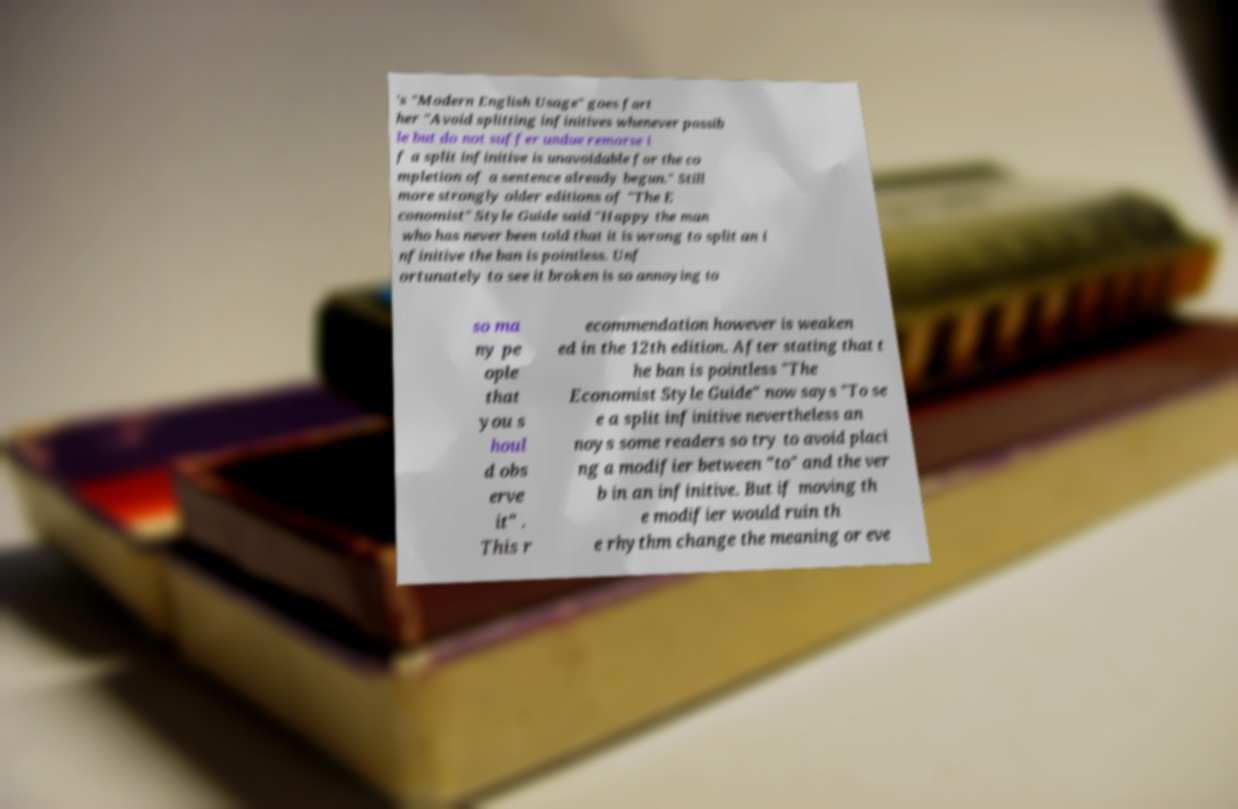What messages or text are displayed in this image? I need them in a readable, typed format. 's "Modern English Usage" goes fart her "Avoid splitting infinitives whenever possib le but do not suffer undue remorse i f a split infinitive is unavoidable for the co mpletion of a sentence already begun." Still more strongly older editions of "The E conomist" Style Guide said "Happy the man who has never been told that it is wrong to split an i nfinitive the ban is pointless. Unf ortunately to see it broken is so annoying to so ma ny pe ople that you s houl d obs erve it" . This r ecommendation however is weaken ed in the 12th edition. After stating that t he ban is pointless "The Economist Style Guide" now says "To se e a split infinitive nevertheless an noys some readers so try to avoid placi ng a modifier between "to" and the ver b in an infinitive. But if moving th e modifier would ruin th e rhythm change the meaning or eve 